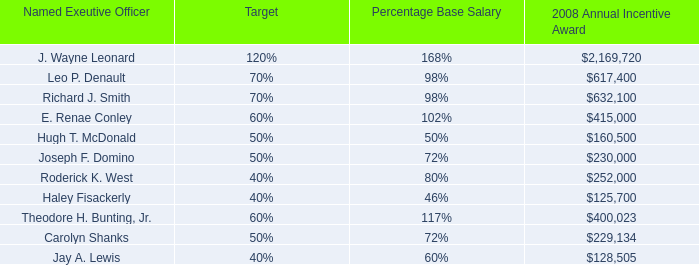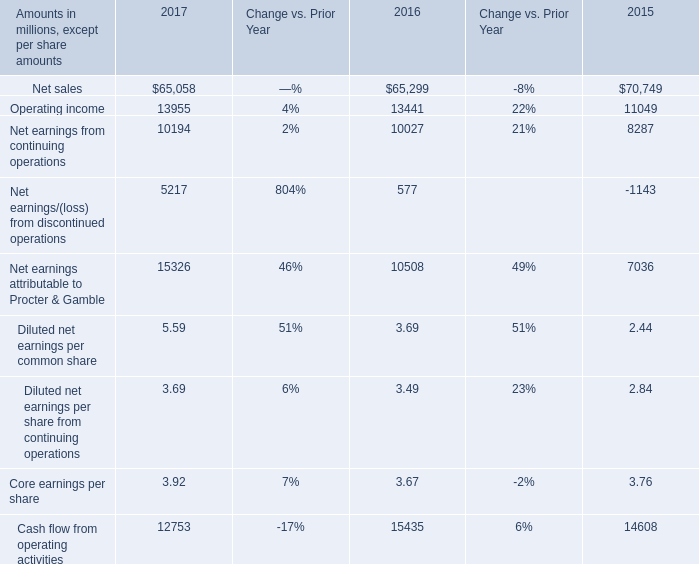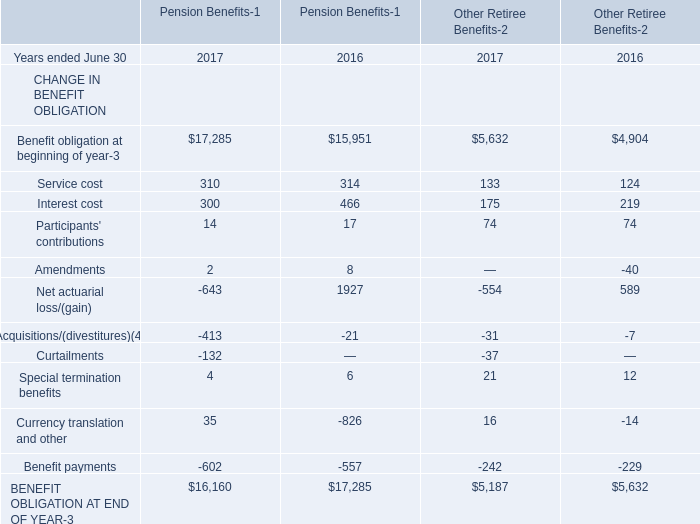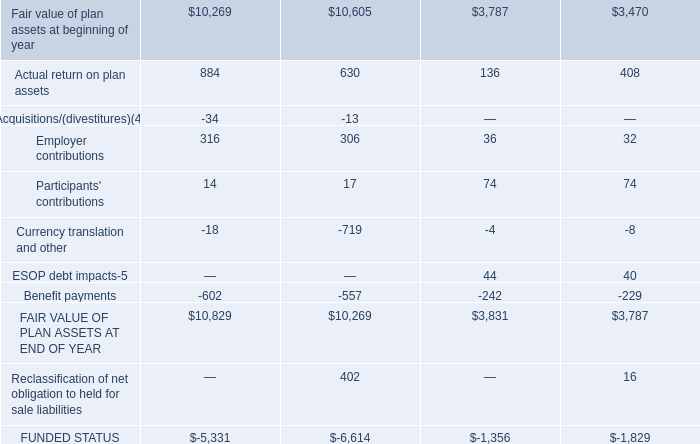Which year ended June 30 is Interest cost for Pension Benefits the lowest? 
Answer: 2017. 